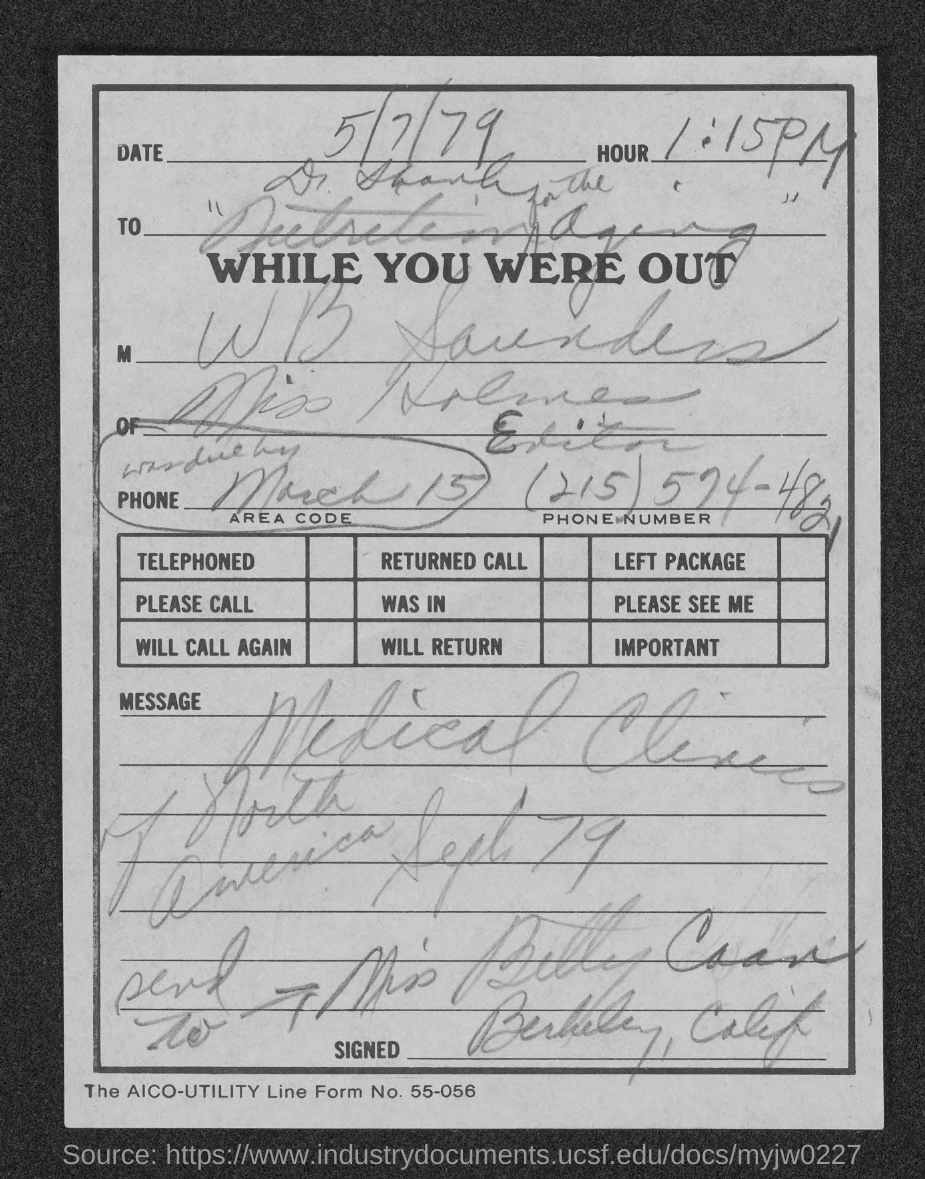Indicate a few pertinent items in this graphic. The issued date of this document is May 7th, 1979. The phone number mentioned in this document is (215) 574-4821. The time mentioned in the document is 1:15 PM. 